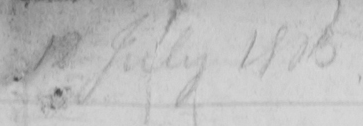What text is written in this handwritten line? 12 July 1803 